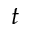Convert formula to latex. <formula><loc_0><loc_0><loc_500><loc_500>t</formula> 